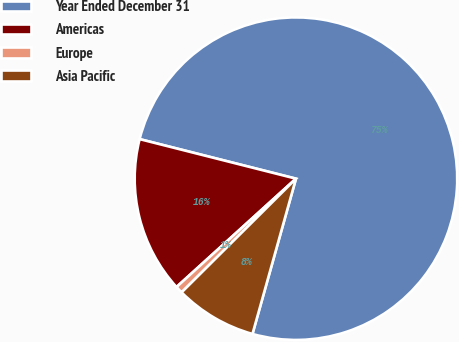<chart> <loc_0><loc_0><loc_500><loc_500><pie_chart><fcel>Year Ended December 31<fcel>Americas<fcel>Europe<fcel>Asia Pacific<nl><fcel>75.4%<fcel>15.67%<fcel>0.73%<fcel>8.2%<nl></chart> 